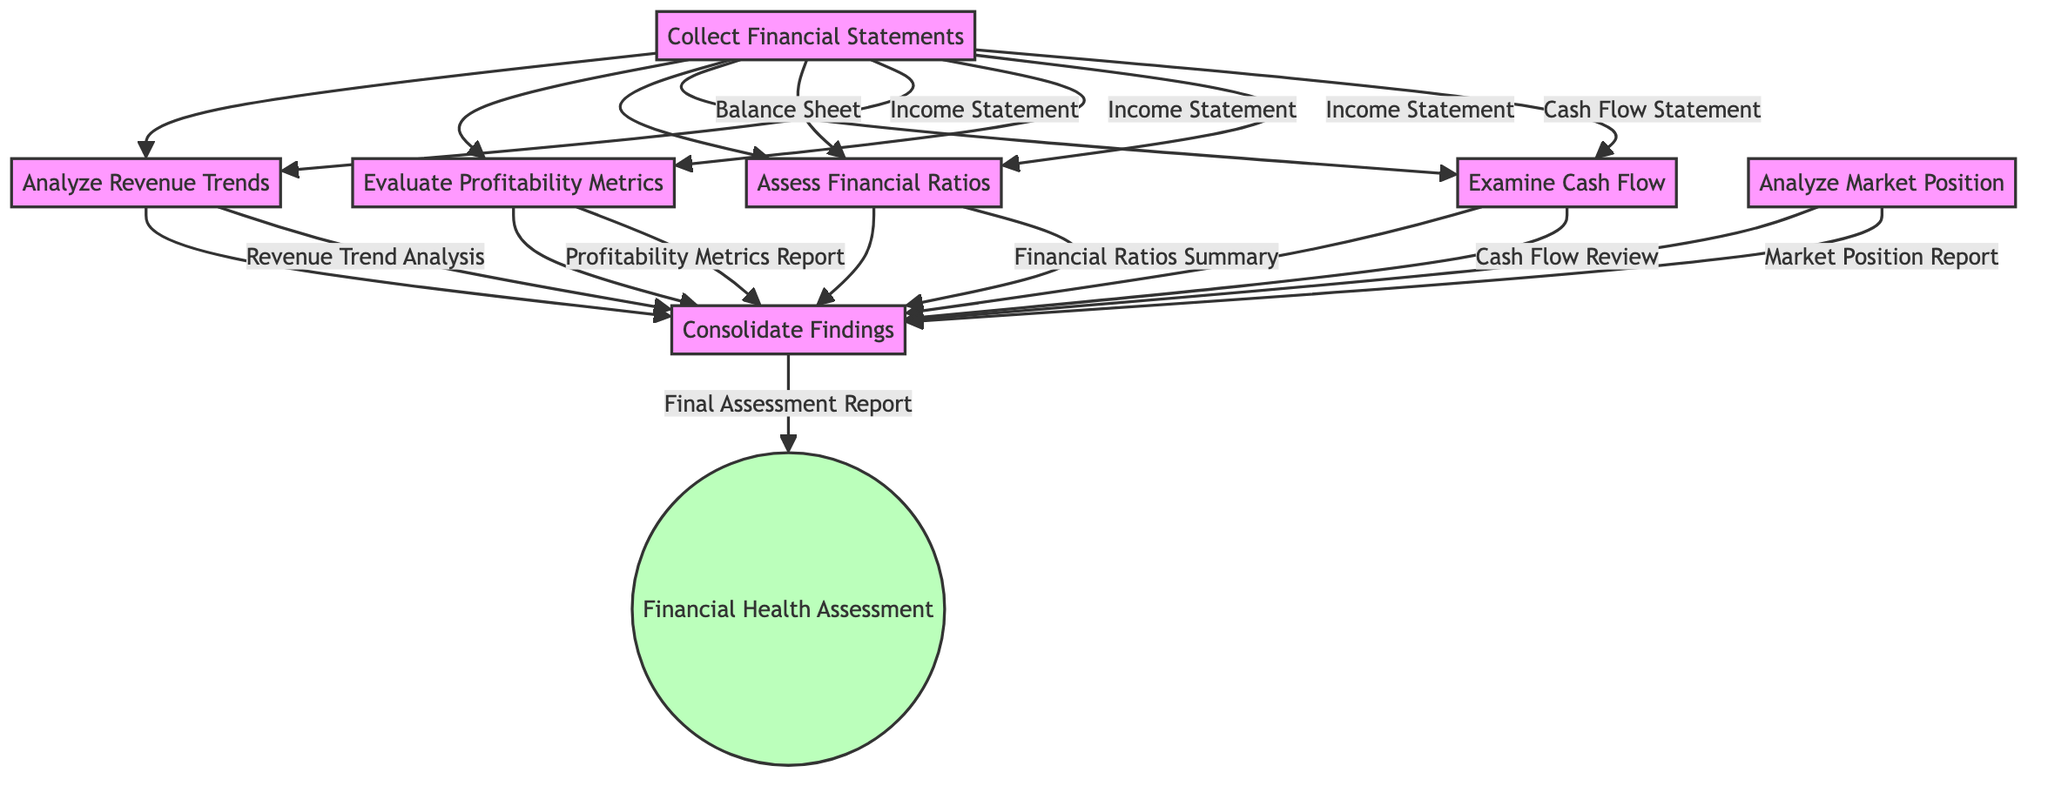What is the first step in the process? The diagram shows that the first step is "Collect Financial Statements." This is indicated at the top of the flowchart, leading to various subsequent analysis steps.
Answer: Collect Financial Statements How many companies are listed in the collecting data step? In the "Collect Financial Statements" step, there are three companies mentioned: Tesla, Ford, and General Motors. This can be seen in the details section of the first node.
Answer: Three What inputs are needed to assess financial ratios? To assess financial ratios, the inputs required are the "Balance Sheet" and the "Income Statement." This can be directly traced from the nodes leading into the "Assess Financial Ratios" box.
Answer: Balance Sheet, Income Statement What is the final output of the process? The final output of the entire flowchart is labeled as "Final Assessment Report," which is shown as the output of the last consolidation step.
Answer: Final Assessment Report Which step analyzes cash flow? The step that specifically analyzes cash flow is labeled "Examine Cash Flow." This can be seen as a distinct step in the flowchart that leads towards the consolidation of findings.
Answer: Examine Cash Flow What outputs result from analyzing revenue trends? The output generated from analyzing revenue trends is "Revenue Trend Analysis," which is connected to the final consolidation node in the diagram.
Answer: Revenue Trend Analysis How many outputs are produced from the "Consolidate Findings" step? The "Consolidate Findings" step produces only one output, which is the "Final Assessment Report." The diagram clearly indicates this as the terminal output of that step.
Answer: One What methods are used in the step for evaluating profitability metrics? The methods used in the "Evaluate Profitability Metrics" step are "Net Profit Margin Calculation" and "Operating Margin Analysis." These methods are listed in the specifics of that node.
Answer: Net Profit Margin Calculation, Operating Margin Analysis Which step is dependent on analyzing market position? The "Consolidate Findings" step is dependent on the "Analyze Market Position" step since it leads into the consolidation node alongside other analyses. Thus, analyzing market position is crucial for obtaining the final assessment.
Answer: Consolidate Findings 